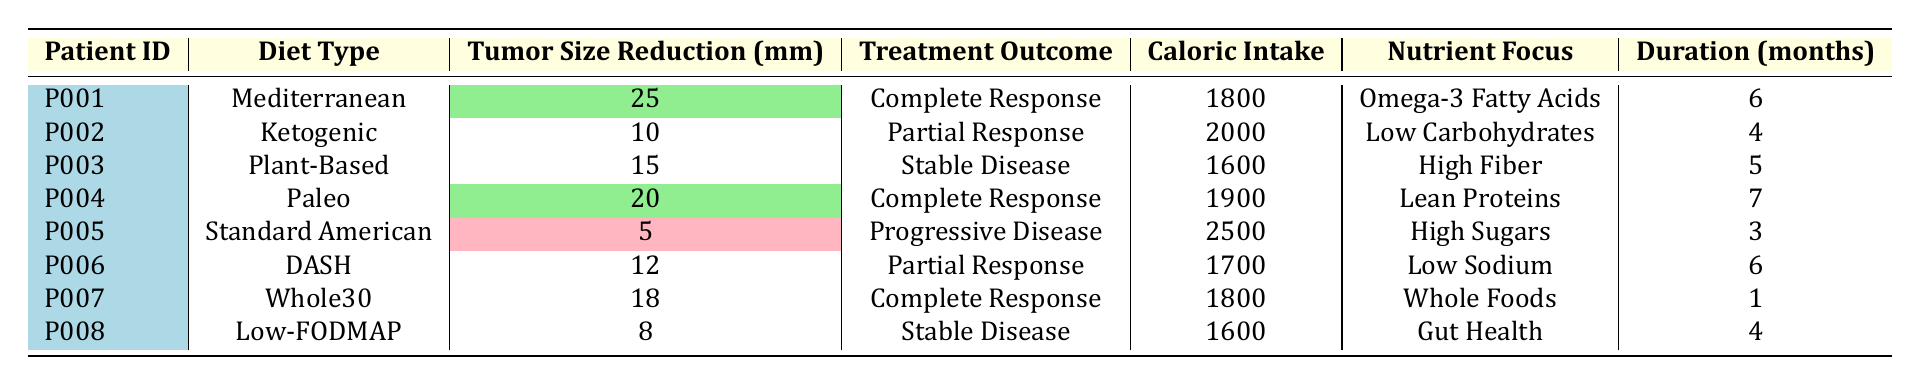What is the tumor size reduction for patient P001? The table shows that patient P001 had a tumor size reduction of 25 mm.
Answer: 25 mm Which diet resulted in the highest tumor size reduction? By comparing the tumor size reductions listed, the Mediterranean diet for patient P001 resulted in the highest reduction of 25 mm.
Answer: Mediterranean diet What is the treatment outcome for the patient with the lowest tumor size reduction? Patient P005, who followed the Standard American diet, had the lowest tumor size reduction at 5 mm. The treatment outcome recorded for this patient was Progressive Disease.
Answer: Progressive Disease How many patients had a complete response? Looking through the treatment outcomes, there are three patients (P001, P004, and P007) that achieved a complete response.
Answer: 3 patients What is the average caloric intake of patients who achieved a complete response? The patients with complete responses (P001, P004, P007) had caloric intakes of 1800, 1900, and 1800. Summing these gives 1800 + 1900 + 1800 = 5500. Dividing by 3 gives an average caloric intake of 5500 / 3 = 1833.33.
Answer: 1833.33 Is there any patient on a ketogenic diet who achieved a complete response? The table notes that patient P002 followed a ketogenic diet and had a treatment outcome of Partial Response, indicating they did not achieve a complete response.
Answer: No What is the total tumor size reduction for all patients on a Mediterranean or Paleo diet? Patient P001 (Mediterranean) had a reduction of 25 mm and patient P004 (Paleo) had a reduction of 20 mm. Adding these together gives 25 + 20 = 45 mm total tumor size reduction from these diets.
Answer: 45 mm Which diet had the lowest caloric intake among all patients? Comparing the caloric intakes listed reveals patient P003 on a Plant-Based diet had the lowest caloric intake of 1600.
Answer: Plant-Based diet How many patients maintained their tumor size (stable disease) after treatment? There are two patients (P003 and P008) who had their treatment outcomes classified as Stable Disease, which can be seen in the treatment outcome column.
Answer: 2 patients What percentage of patients experienced a Progressive Disease outcome? Out of the 8 patients, 1 experienced Progressive Disease (P005). Calculating the percentage gives (1/8) * 100 = 12.5%.
Answer: 12.5% 